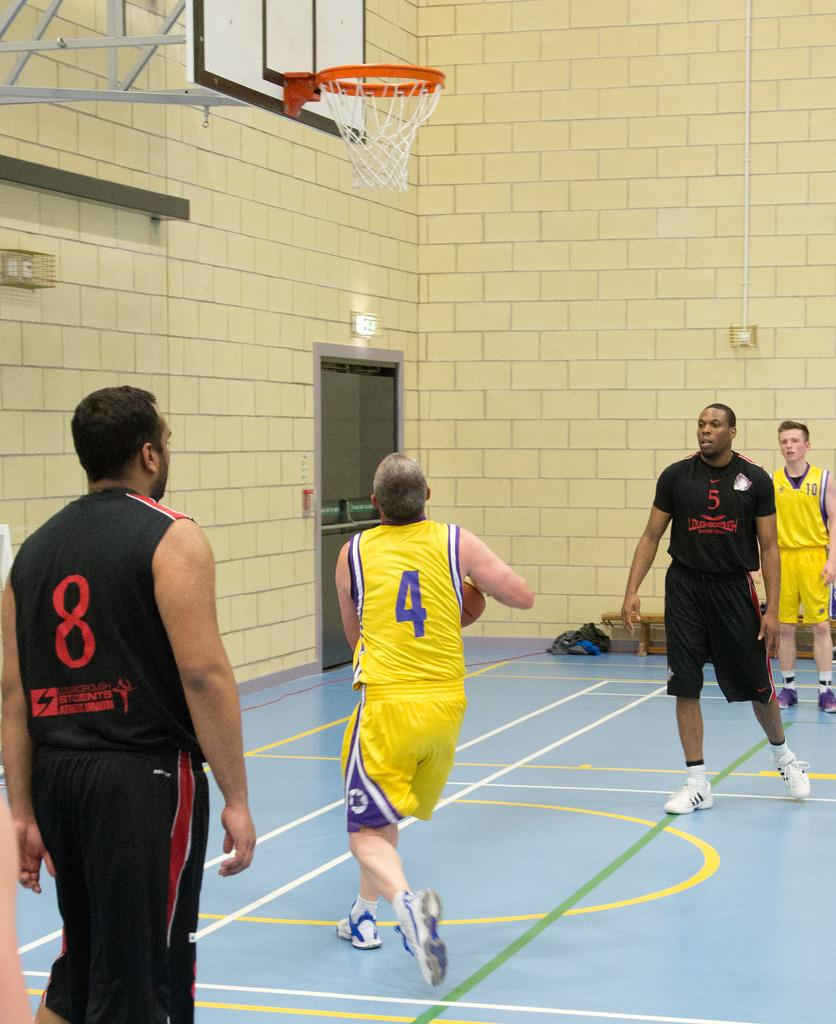<image>
Describe the image concisely. A basketball player has the number 4 on the back of his jersey. 